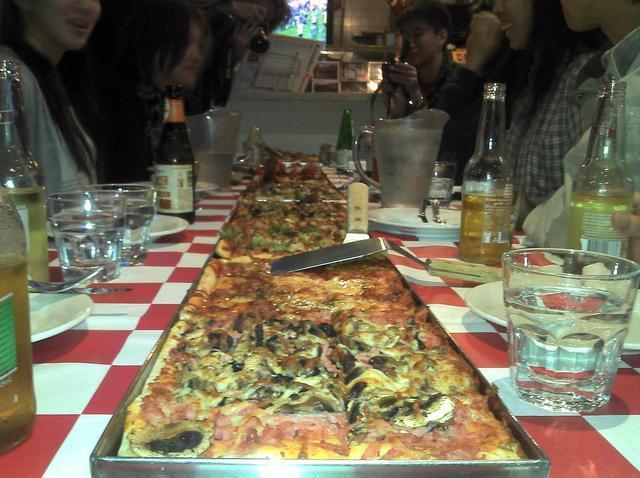How many pizzas are on the table?
Give a very brief answer. 4. How many knives are there?
Give a very brief answer. 1. How many people are there?
Give a very brief answer. 8. How many bottles are in the picture?
Give a very brief answer. 5. How many cups are in the picture?
Give a very brief answer. 5. 